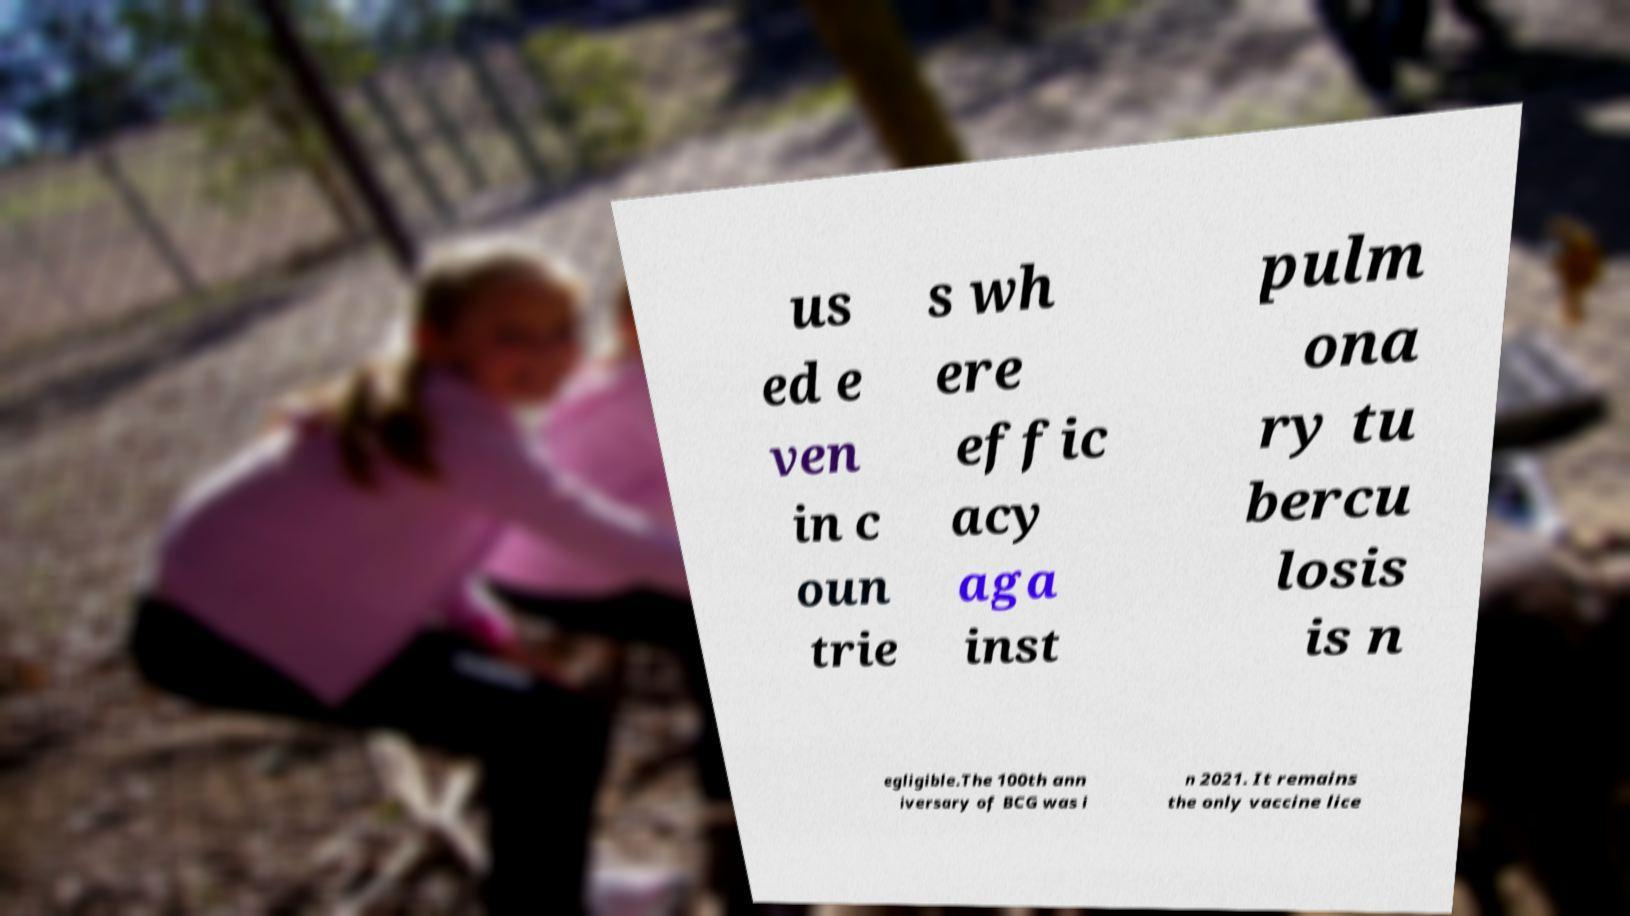What messages or text are displayed in this image? I need them in a readable, typed format. us ed e ven in c oun trie s wh ere effic acy aga inst pulm ona ry tu bercu losis is n egligible.The 100th ann iversary of BCG was i n 2021. It remains the only vaccine lice 